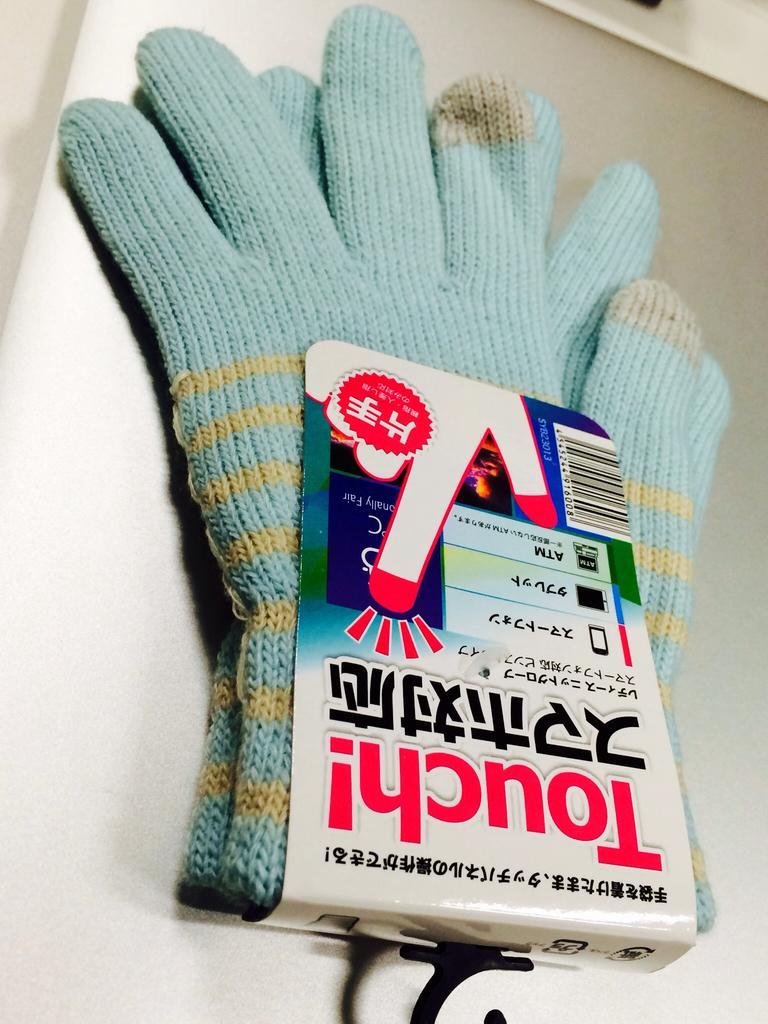Please provide a concise description of this image. In this image we can see there are woolen gloves. 